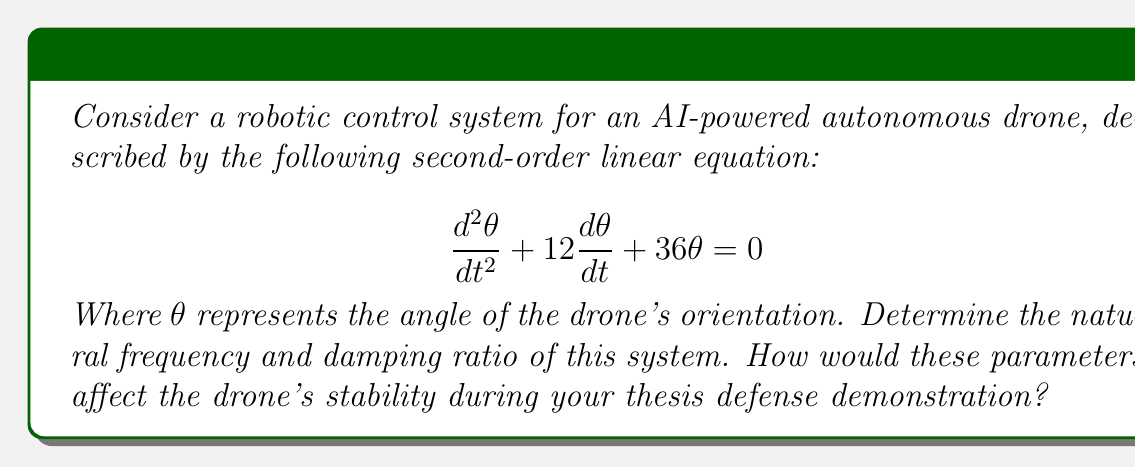Provide a solution to this math problem. To solve this problem, we need to compare the given equation with the standard form of a second-order linear equation:

$$\frac{d^2x}{dt^2} + 2\zeta\omega_n\frac{dx}{dt} + \omega_n^2x = 0$$

Where $\zeta$ is the damping ratio and $\omega_n$ is the natural frequency.

Step 1: Identify the coefficients
In our equation:
$$\frac{d^2\theta}{dt^2} + 12\frac{d\theta}{dt} + 36\theta = 0$$
We can see that:
- The coefficient of $\frac{d\theta}{dt}$ is 12
- The coefficient of $\theta$ is 36

Step 2: Calculate the natural frequency $\omega_n$
The natural frequency is the square root of the coefficient of $\theta$:

$$\omega_n = \sqrt{36} = 6 \text{ rad/s}$$

Step 3: Calculate the damping ratio $\zeta$
Using the coefficient of $\frac{d\theta}{dt}$, we can find $\zeta$:

$$12 = 2\zeta\omega_n$$
$$12 = 2\zeta(6)$$
$$\zeta = \frac{12}{12} = 1$$

The damping ratio is 1, which indicates that this system is critically damped.

Effect on drone stability:
1. Natural frequency ($\omega_n = 6 \text{ rad/s}$): This indicates how quickly the drone would oscillate in the absence of damping. A higher natural frequency means the drone can respond more quickly to disturbances.

2. Damping ratio ($\zeta = 1$): Being critically damped, the drone will return to its desired orientation as quickly as possible without overshooting. This is ideal for stable and precise control during the demonstration.

These parameters suggest that the drone will have a fast response time and excellent stability, which is crucial for a smooth and impressive thesis defense demonstration.
Answer: Natural frequency: $\omega_n = 6 \text{ rad/s}$
Damping ratio: $\zeta = 1$ (critically damped) 